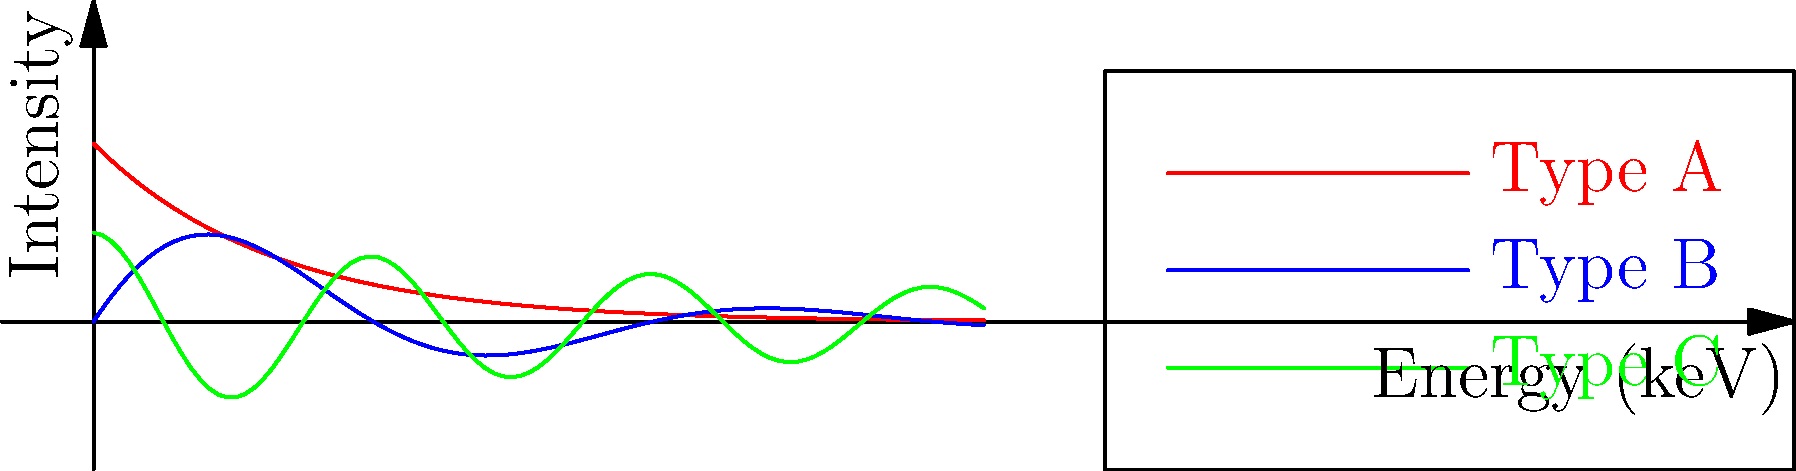Based on the spectral patterns shown in the graph, which type of cosmic radiation source is most likely to exhibit periodic oscillations in its intensity across the energy spectrum? To answer this question, we need to analyze the characteristics of each spectral pattern:

1. Type A (red curve):
   - Smooth, monotonically decreasing function
   - No visible oscillations or periodic behavior
   - Characteristic of exponential decay

2. Type B (blue curve):
   - Shows clear oscillations with decreasing amplitude
   - Combines exponential decay with sinusoidal behavior
   - Periodic pattern is evident across the energy spectrum

3. Type C (green curve):
   - Exhibits rapid oscillations with relatively constant amplitude
   - Combines slow exponential decay with high-frequency cosine function
   - Periodic pattern is present but at a higher frequency than Type B

Among these three types, Type B shows the most pronounced periodic oscillations that are easily discernible across the energy spectrum. The sinusoidal component in its function, $\sin(x)$, is responsible for these oscillations.

Type C also shows periodic behavior, but its higher frequency makes it less likely to be classified as exhibiting clear periodic oscillations in intensity across the spectrum.

Type A shows no periodic behavior at all.

Therefore, Type B is most likely to exhibit periodic oscillations in its intensity across the energy spectrum.
Answer: Type B 